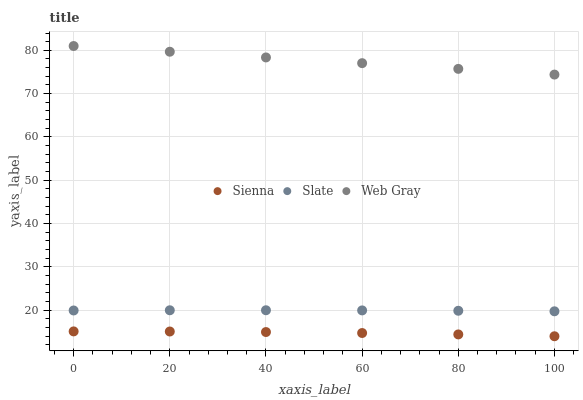Does Sienna have the minimum area under the curve?
Answer yes or no. Yes. Does Web Gray have the maximum area under the curve?
Answer yes or no. Yes. Does Slate have the minimum area under the curve?
Answer yes or no. No. Does Slate have the maximum area under the curve?
Answer yes or no. No. Is Web Gray the smoothest?
Answer yes or no. Yes. Is Sienna the roughest?
Answer yes or no. Yes. Is Slate the smoothest?
Answer yes or no. No. Is Slate the roughest?
Answer yes or no. No. Does Sienna have the lowest value?
Answer yes or no. Yes. Does Slate have the lowest value?
Answer yes or no. No. Does Web Gray have the highest value?
Answer yes or no. Yes. Does Slate have the highest value?
Answer yes or no. No. Is Sienna less than Web Gray?
Answer yes or no. Yes. Is Web Gray greater than Sienna?
Answer yes or no. Yes. Does Sienna intersect Web Gray?
Answer yes or no. No. 